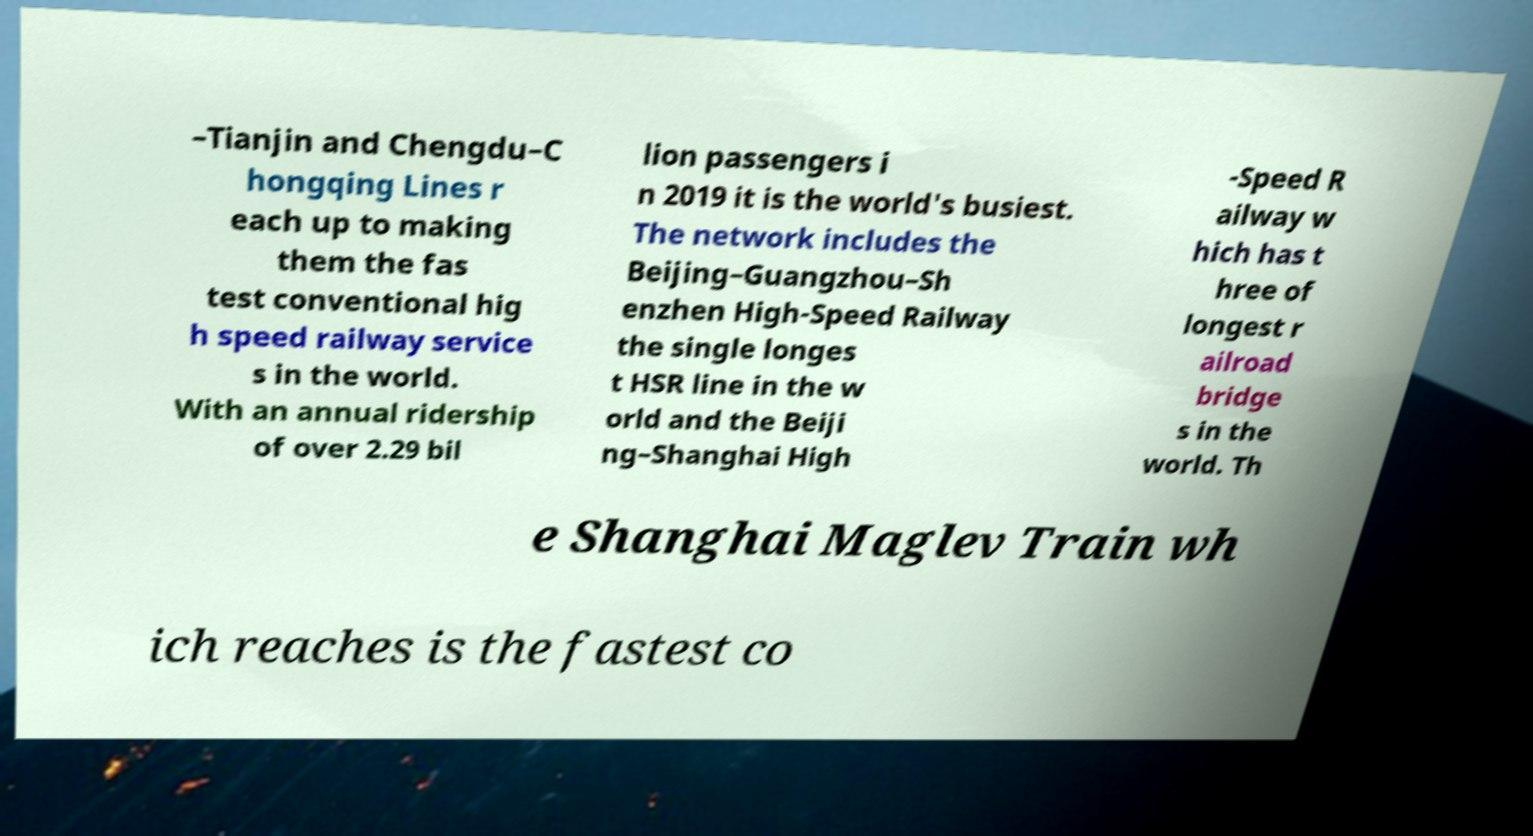Could you assist in decoding the text presented in this image and type it out clearly? –Tianjin and Chengdu–C hongqing Lines r each up to making them the fas test conventional hig h speed railway service s in the world. With an annual ridership of over 2.29 bil lion passengers i n 2019 it is the world's busiest. The network includes the Beijing–Guangzhou–Sh enzhen High-Speed Railway the single longes t HSR line in the w orld and the Beiji ng–Shanghai High -Speed R ailway w hich has t hree of longest r ailroad bridge s in the world. Th e Shanghai Maglev Train wh ich reaches is the fastest co 